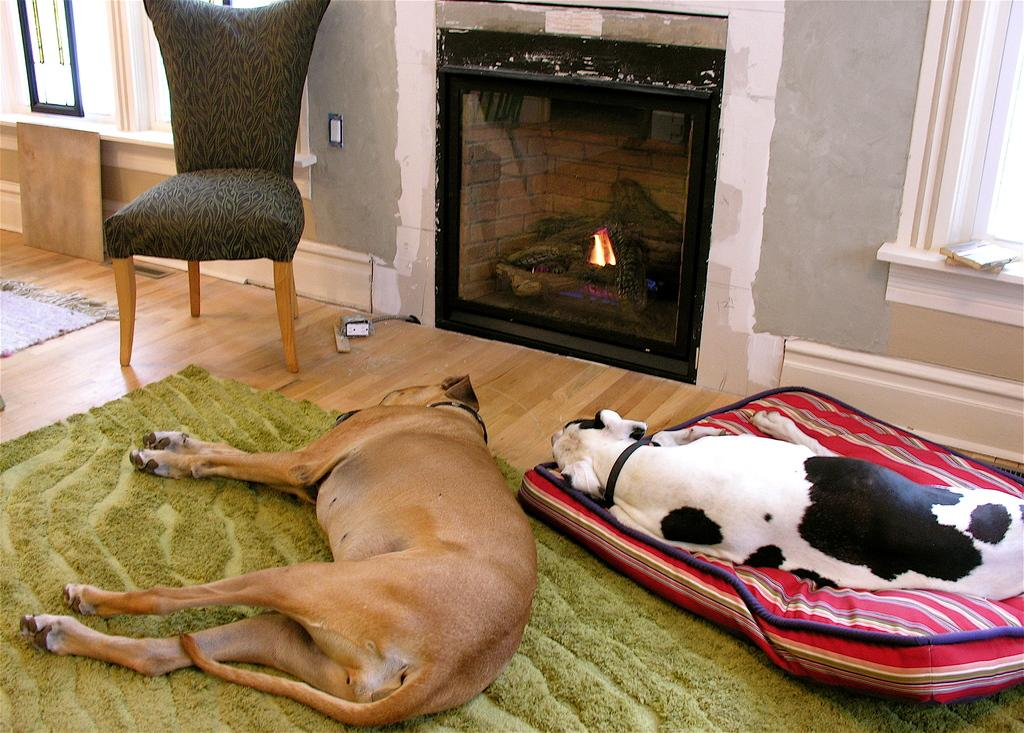How many dogs are present in the image? There are two dogs in the image. What are the dogs doing in the image? The dogs are sleeping on the floor. Can you describe any other objects or furniture in the image? There is a chair visible at the top of the image. What type of bells can be heard ringing in the image? There are no bells present in the image, and therefore no sound can be heard. 